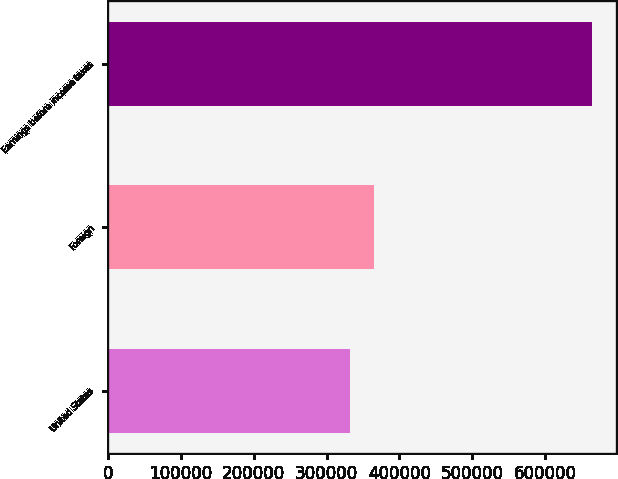Convert chart. <chart><loc_0><loc_0><loc_500><loc_500><bar_chart><fcel>United States<fcel>Foreign<fcel>Earnings before income taxes<nl><fcel>331553<fcel>364787<fcel>663891<nl></chart> 